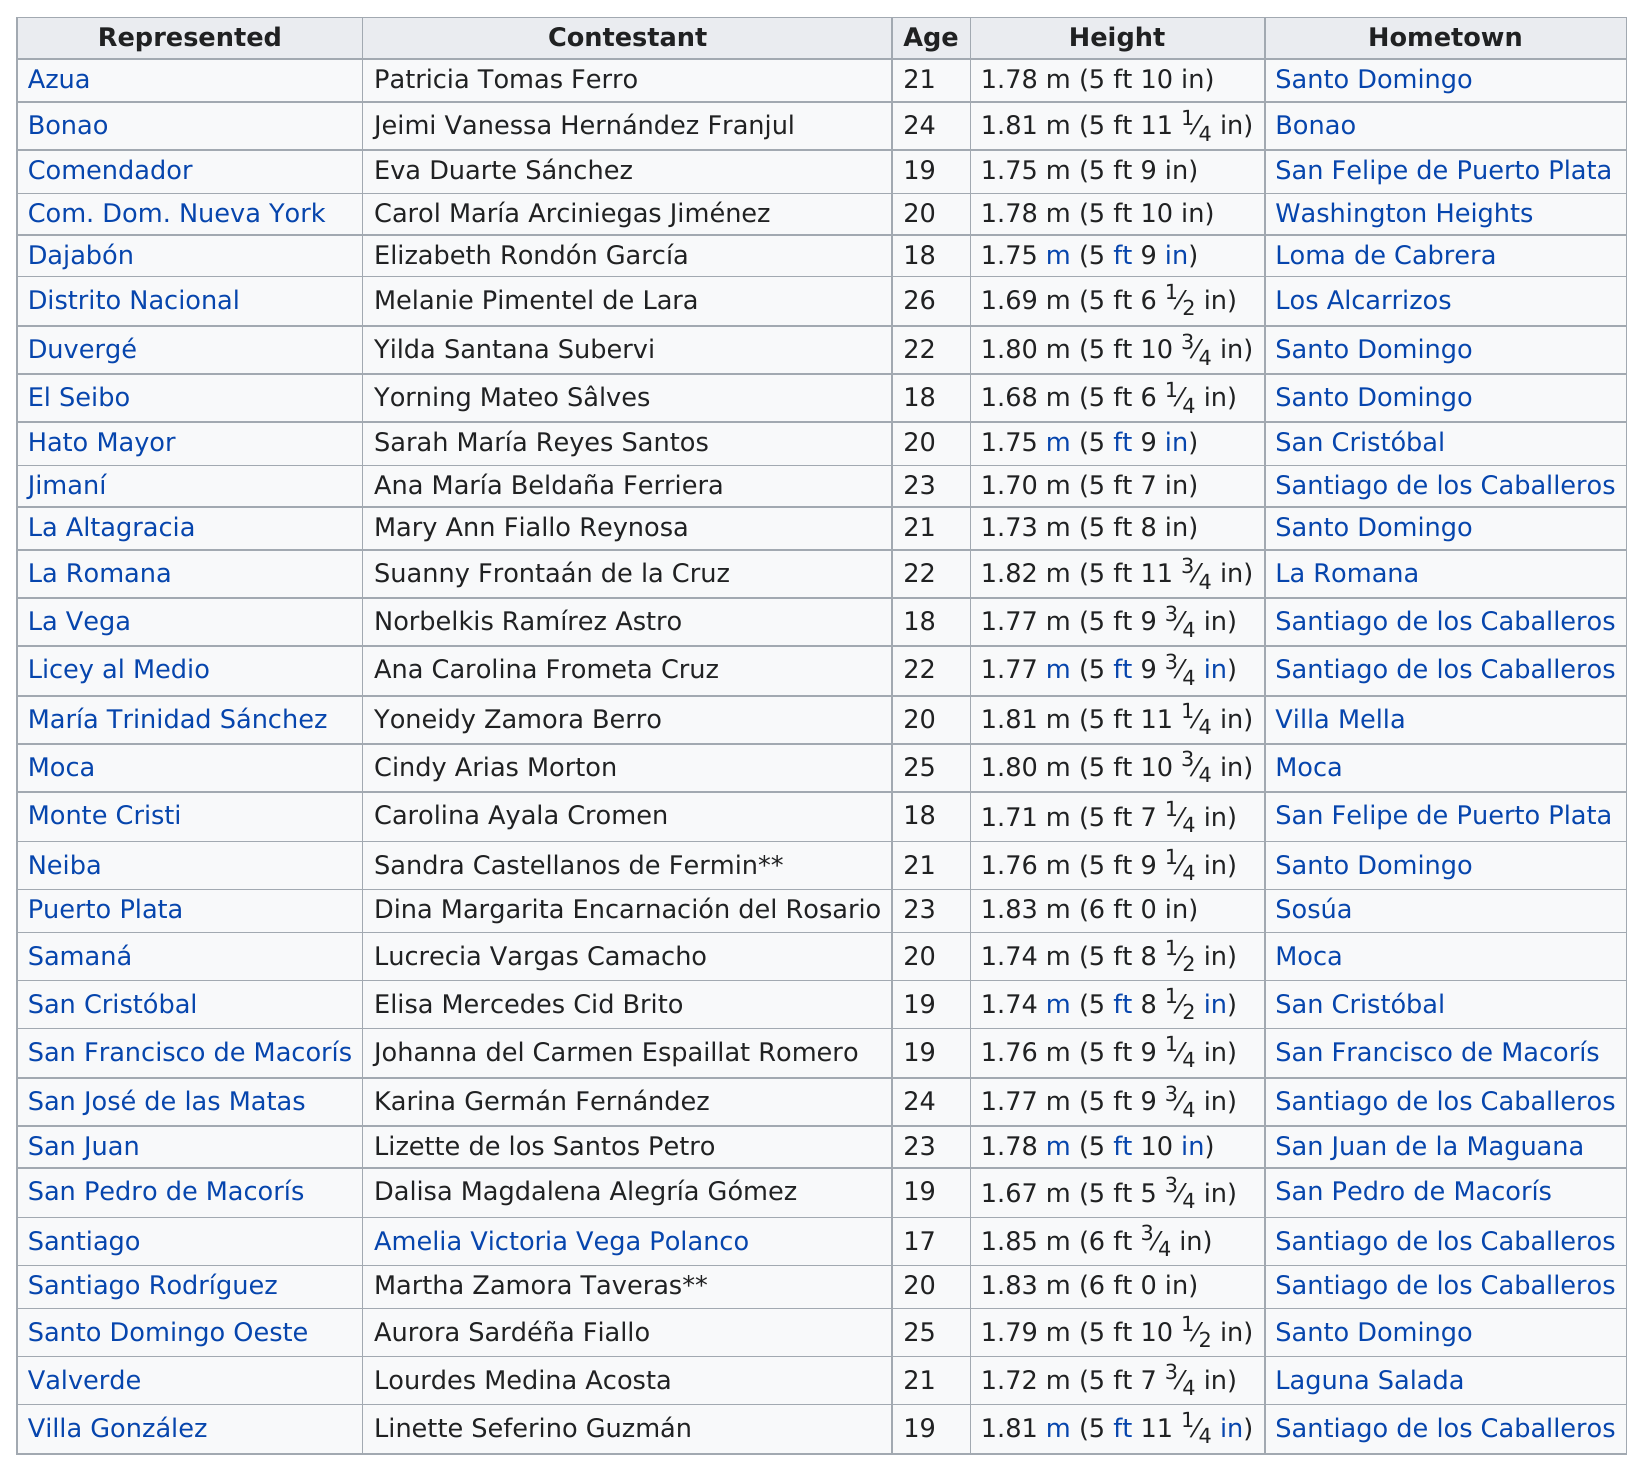Highlight a few significant elements in this photo. In 2002, the Miss Dominican Republic pageant was represented by 30 delegates from various areas. Melanie Pimentel de Lara is the oldest delegate. The delegate named Amelia Victoria Vega Polanco is the tallest person. Of the delegates, how many are taller than 1.80 meters? Miss Amelia Victoria Vega Polanco was the youngest delegate for Dominican Republic in 2002. 